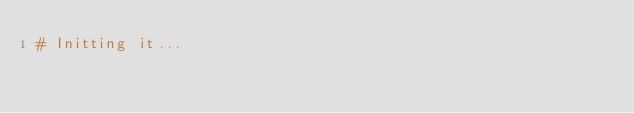<code> <loc_0><loc_0><loc_500><loc_500><_Python_># Initting it...
</code> 